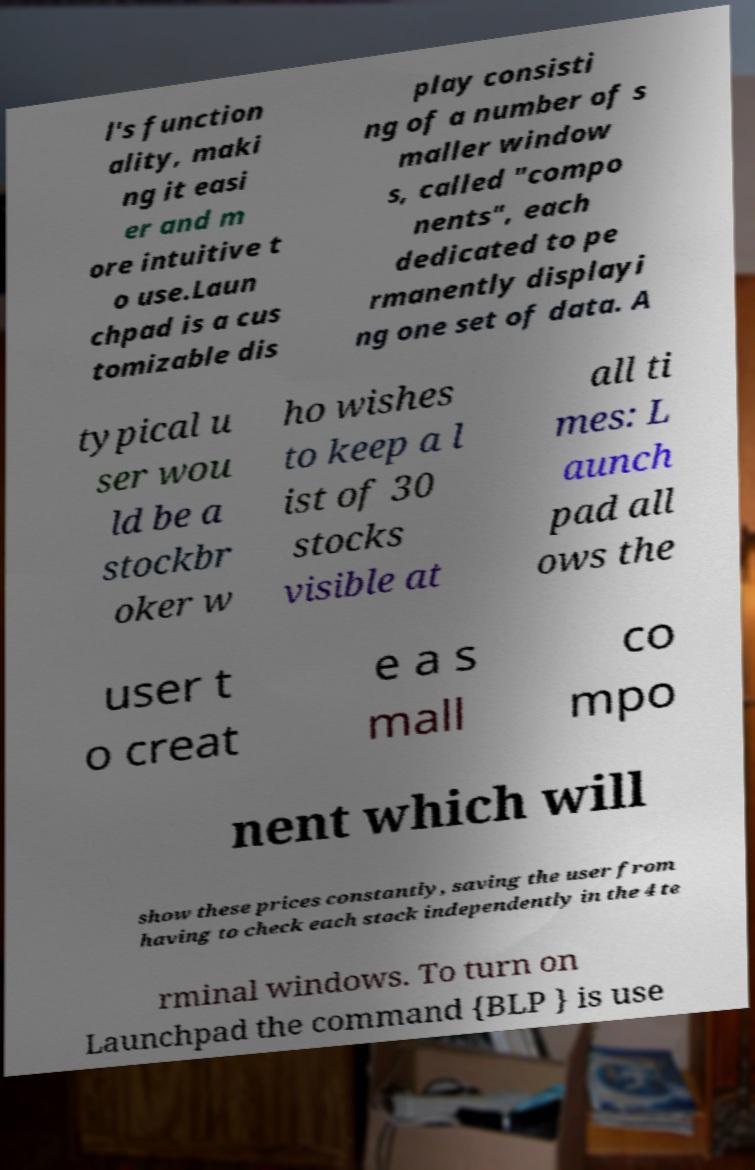Please read and relay the text visible in this image. What does it say? l's function ality, maki ng it easi er and m ore intuitive t o use.Laun chpad is a cus tomizable dis play consisti ng of a number of s maller window s, called "compo nents", each dedicated to pe rmanently displayi ng one set of data. A typical u ser wou ld be a stockbr oker w ho wishes to keep a l ist of 30 stocks visible at all ti mes: L aunch pad all ows the user t o creat e a s mall co mpo nent which will show these prices constantly, saving the user from having to check each stock independently in the 4 te rminal windows. To turn on Launchpad the command {BLP } is use 